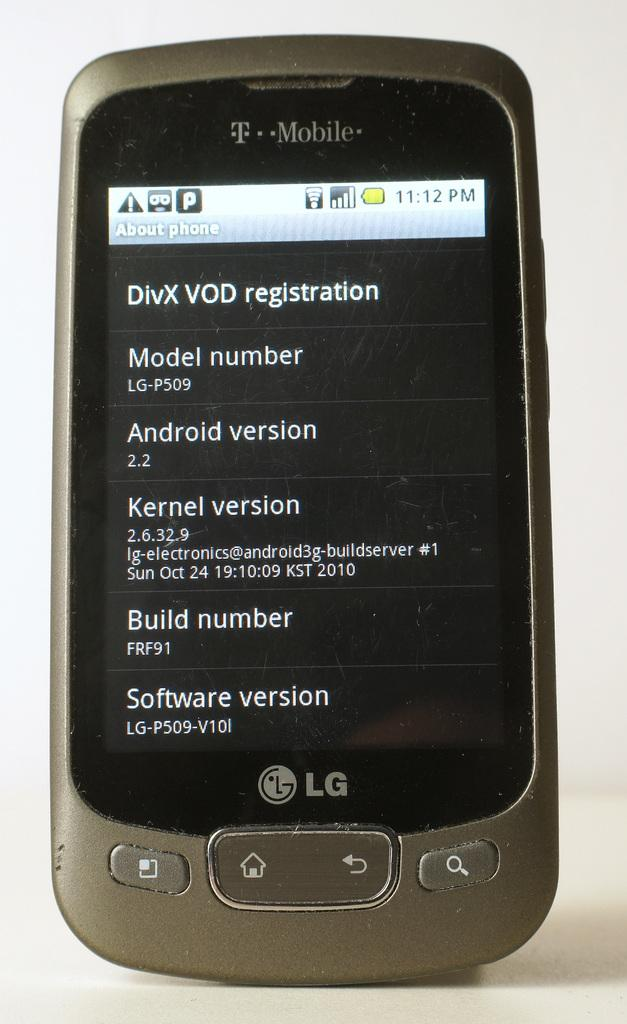<image>
Offer a succinct explanation of the picture presented. A gray T-mobile device with an information screen showing. 